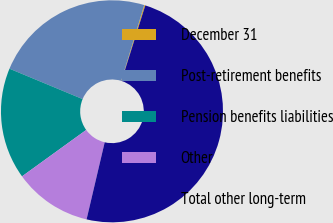Convert chart to OTSL. <chart><loc_0><loc_0><loc_500><loc_500><pie_chart><fcel>December 31<fcel>Post-retirement benefits<fcel>Pension benefits liabilities<fcel>Other<fcel>Total other long-term<nl><fcel>0.16%<fcel>23.42%<fcel>16.23%<fcel>11.36%<fcel>48.82%<nl></chart> 